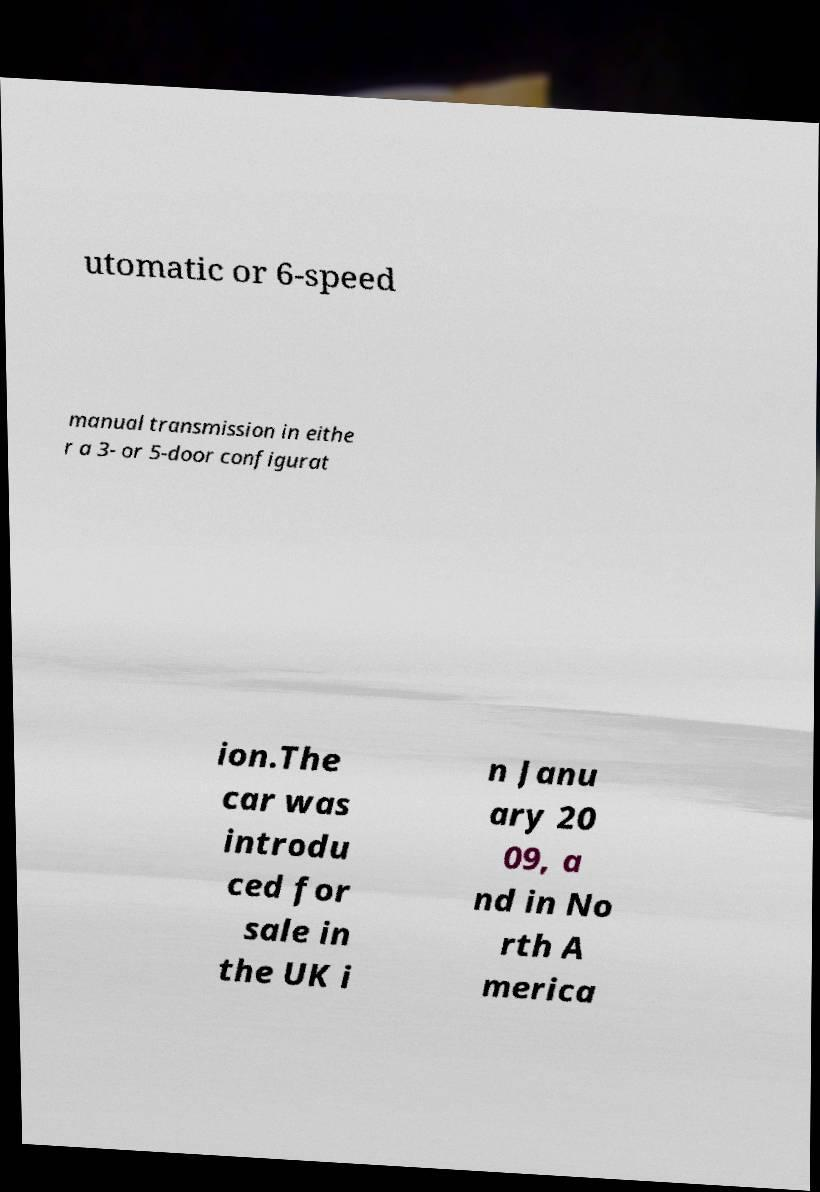For documentation purposes, I need the text within this image transcribed. Could you provide that? utomatic or 6-speed manual transmission in eithe r a 3- or 5-door configurat ion.The car was introdu ced for sale in the UK i n Janu ary 20 09, a nd in No rth A merica 